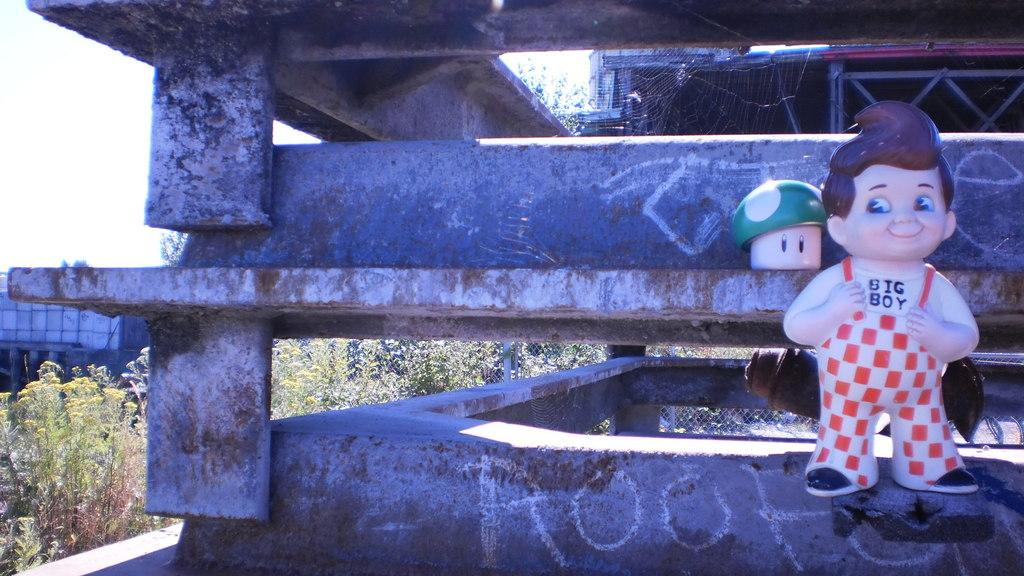What type of structures can be seen in the image? There are buildings in the image. What other objects are present in the image? There are toys, a mesh, a web, rods, and trees in the image. Can you see an uncle interacting with the worm through the window in the image? There is no uncle, worm, or window present in the image. 